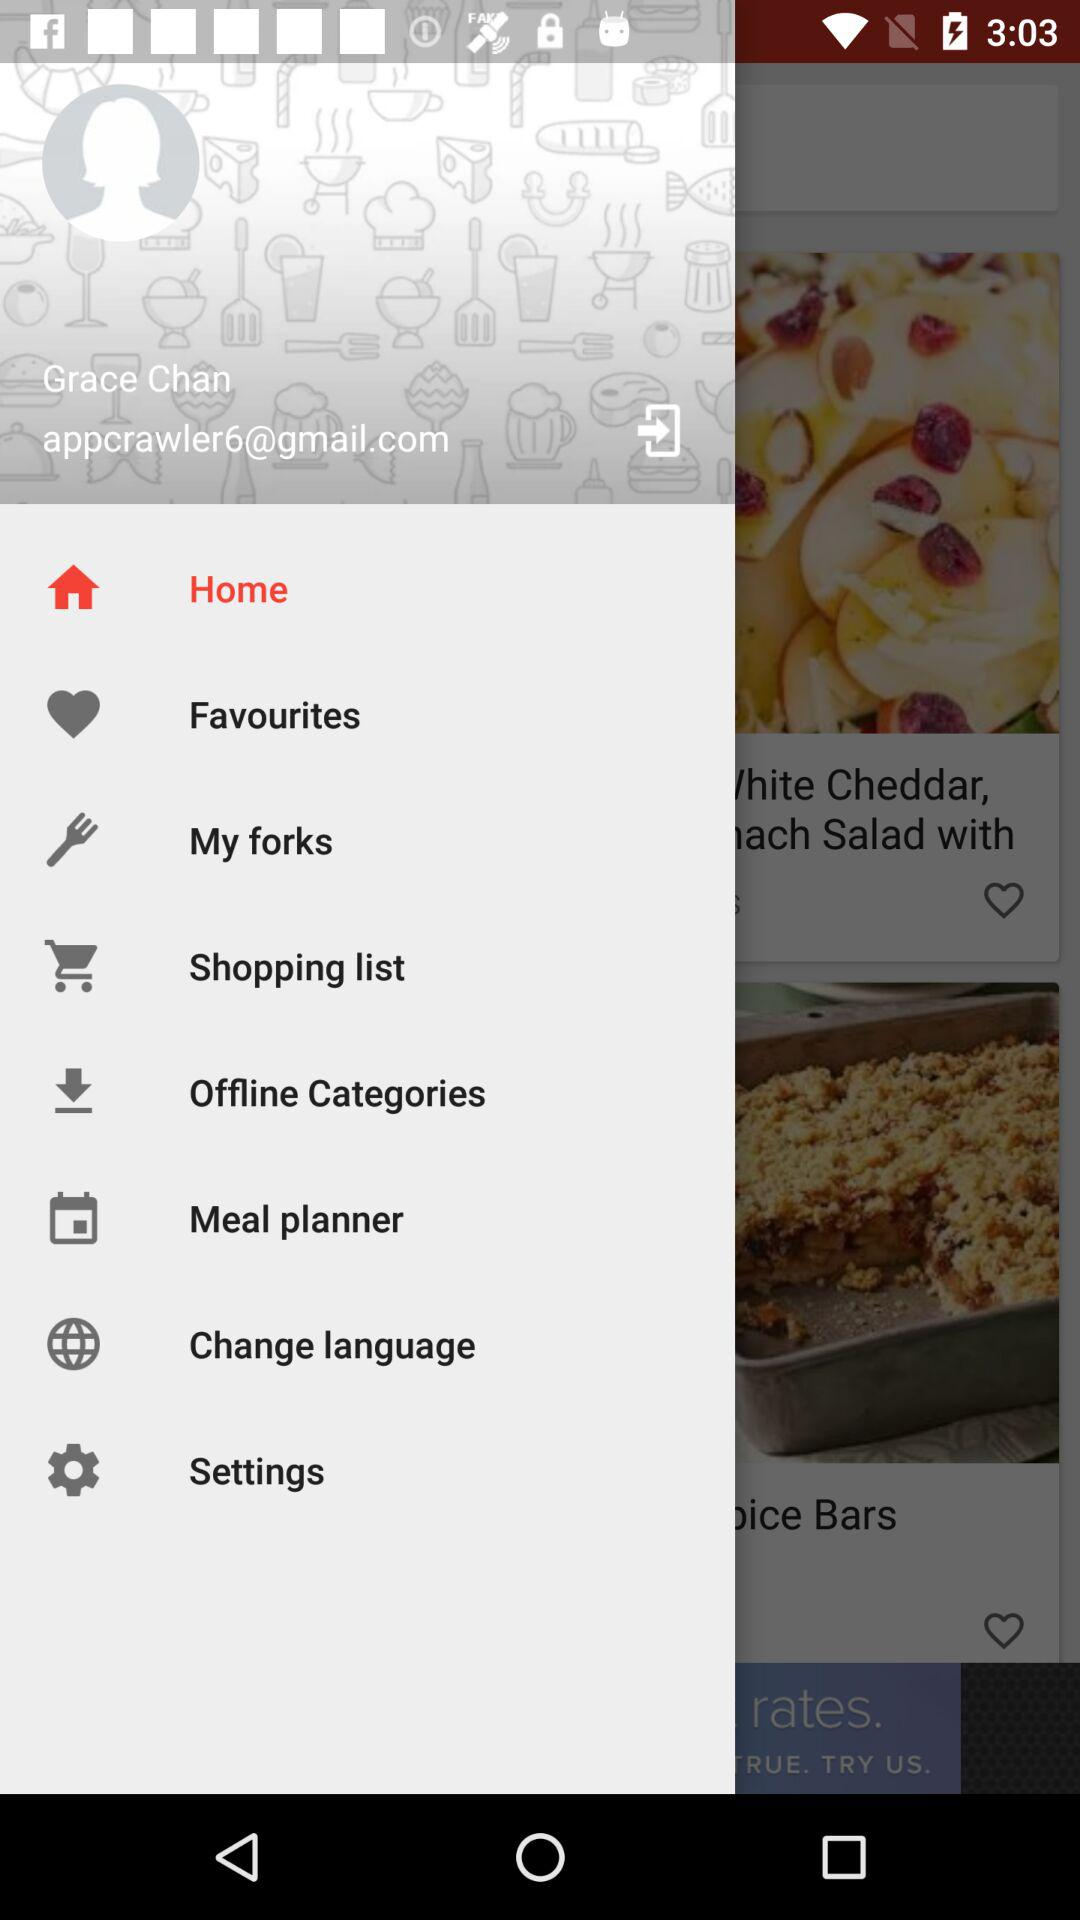What is the profile name? The profile name is Grace Chan. 